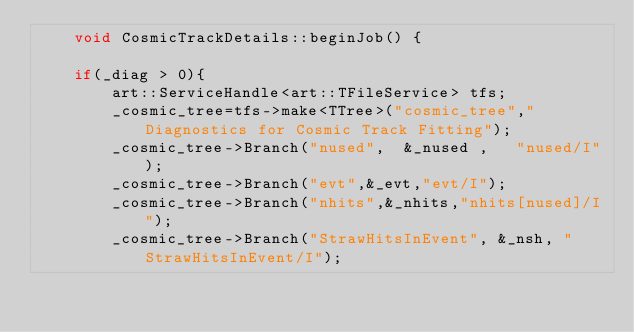<code> <loc_0><loc_0><loc_500><loc_500><_C++_>    void CosmicTrackDetails::beginJob() {

	if(_diag > 0){
		art::ServiceHandle<art::TFileService> tfs;
		_cosmic_tree=tfs->make<TTree>("cosmic_tree"," Diagnostics for Cosmic Track Fitting");
		_cosmic_tree->Branch("nused",  &_nused ,   "nused/I");
		_cosmic_tree->Branch("evt",&_evt,"evt/I");
		_cosmic_tree->Branch("nhits",&_nhits,"nhits[nused]/I");
		_cosmic_tree->Branch("StrawHitsInEvent", &_nsh, "StrawHitsInEvent/I");</code> 